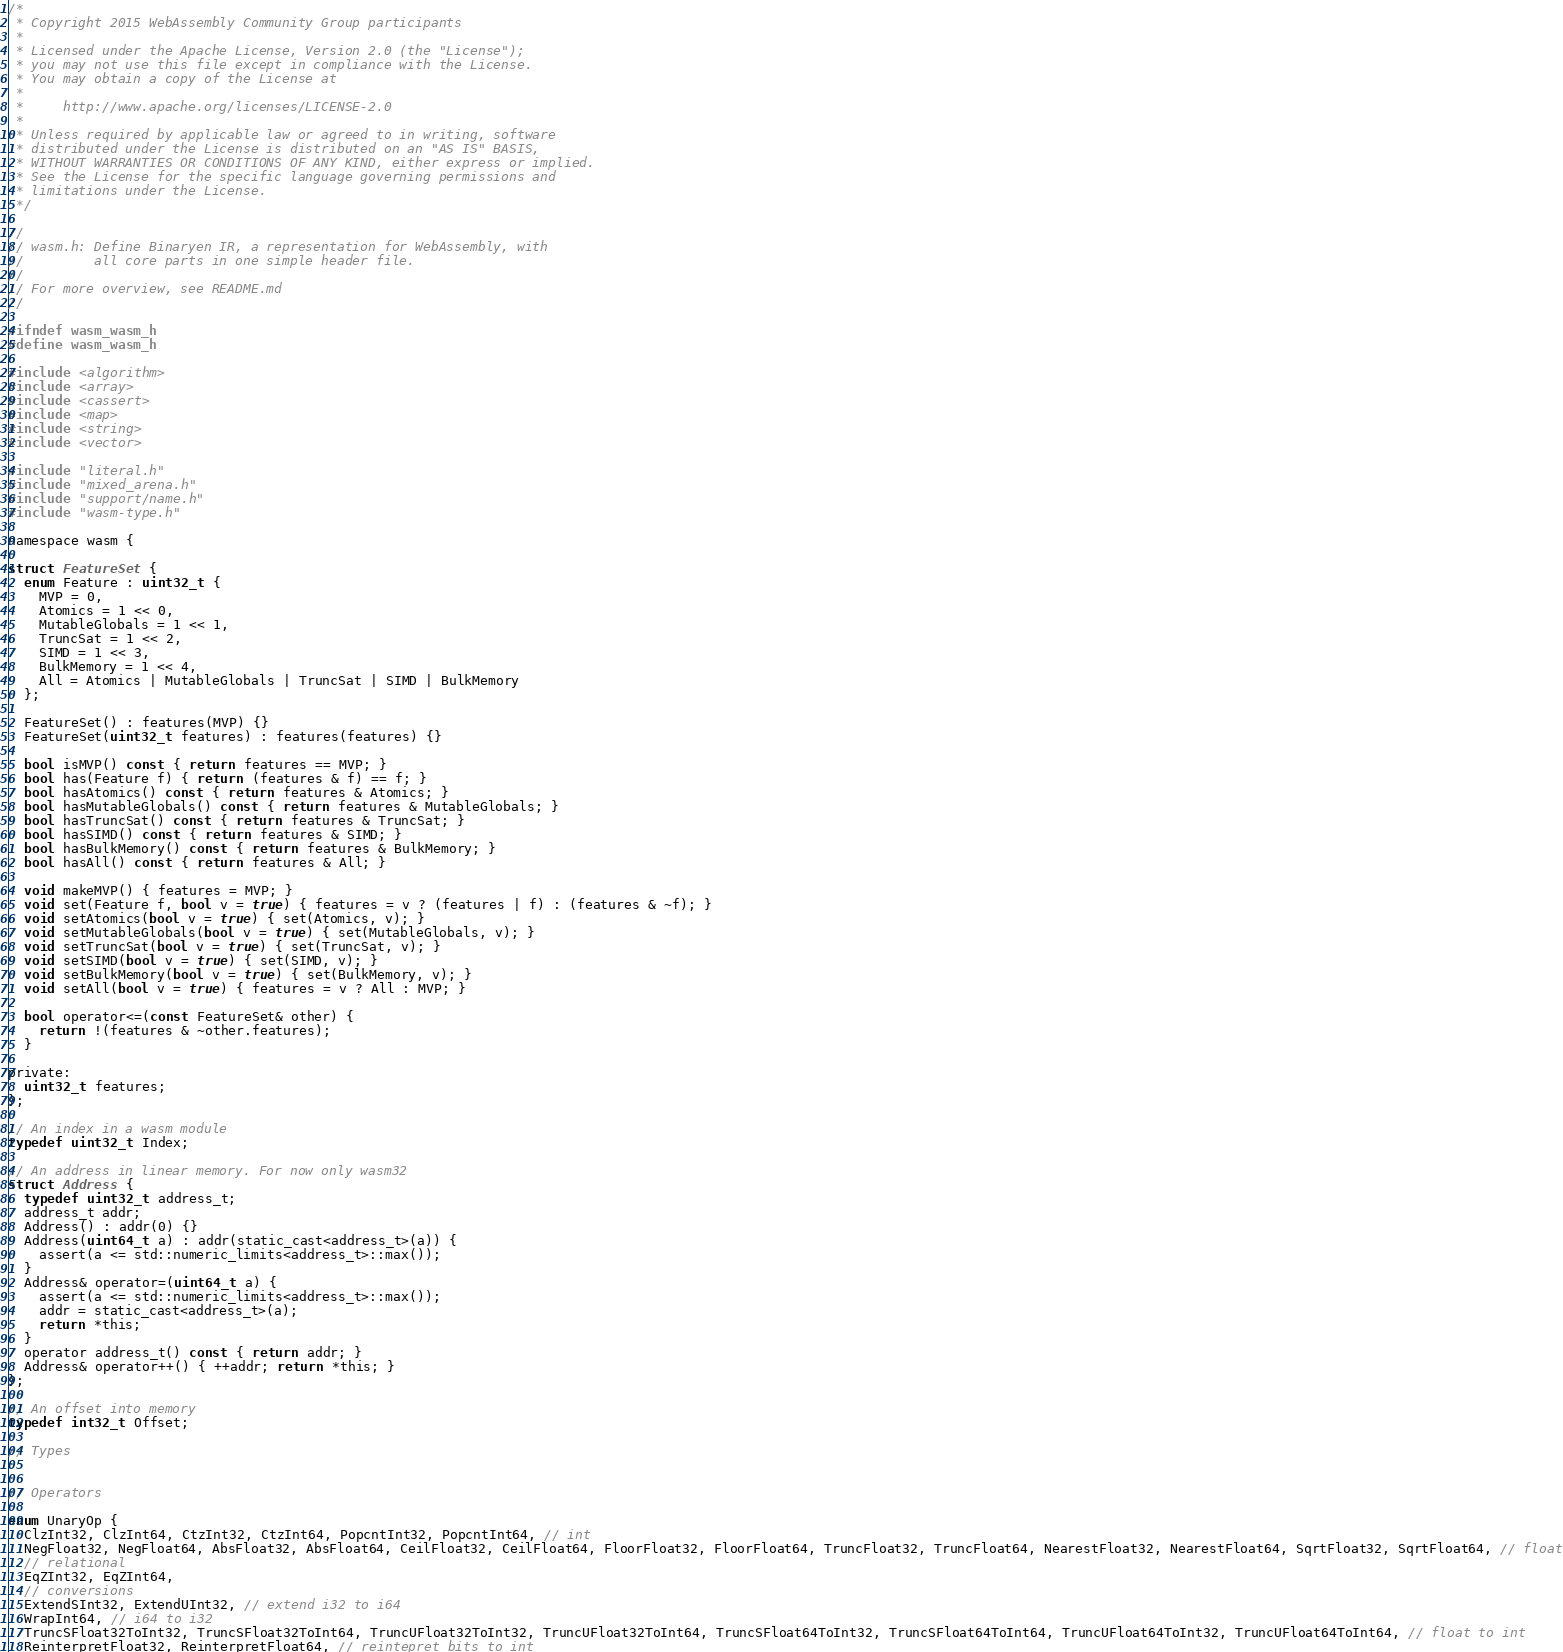Convert code to text. <code><loc_0><loc_0><loc_500><loc_500><_C_>/*
 * Copyright 2015 WebAssembly Community Group participants
 *
 * Licensed under the Apache License, Version 2.0 (the "License");
 * you may not use this file except in compliance with the License.
 * You may obtain a copy of the License at
 *
 *     http://www.apache.org/licenses/LICENSE-2.0
 *
 * Unless required by applicable law or agreed to in writing, software
 * distributed under the License is distributed on an "AS IS" BASIS,
 * WITHOUT WARRANTIES OR CONDITIONS OF ANY KIND, either express or implied.
 * See the License for the specific language governing permissions and
 * limitations under the License.
 */

//
// wasm.h: Define Binaryen IR, a representation for WebAssembly, with
//         all core parts in one simple header file.
//
// For more overview, see README.md
//

#ifndef wasm_wasm_h
#define wasm_wasm_h

#include <algorithm>
#include <array>
#include <cassert>
#include <map>
#include <string>
#include <vector>

#include "literal.h"
#include "mixed_arena.h"
#include "support/name.h"
#include "wasm-type.h"

namespace wasm {

struct FeatureSet {
  enum Feature : uint32_t {
    MVP = 0,
    Atomics = 1 << 0,
    MutableGlobals = 1 << 1,
    TruncSat = 1 << 2,
    SIMD = 1 << 3,
    BulkMemory = 1 << 4,
    All = Atomics | MutableGlobals | TruncSat | SIMD | BulkMemory
  };

  FeatureSet() : features(MVP) {}
  FeatureSet(uint32_t features) : features(features) {}

  bool isMVP() const { return features == MVP; }
  bool has(Feature f) { return (features & f) == f; }
  bool hasAtomics() const { return features & Atomics; }
  bool hasMutableGlobals() const { return features & MutableGlobals; }
  bool hasTruncSat() const { return features & TruncSat; }
  bool hasSIMD() const { return features & SIMD; }
  bool hasBulkMemory() const { return features & BulkMemory; }
  bool hasAll() const { return features & All; }

  void makeMVP() { features = MVP; }
  void set(Feature f, bool v = true) { features = v ? (features | f) : (features & ~f); }
  void setAtomics(bool v = true) { set(Atomics, v); }
  void setMutableGlobals(bool v = true) { set(MutableGlobals, v); }
  void setTruncSat(bool v = true) { set(TruncSat, v); }
  void setSIMD(bool v = true) { set(SIMD, v); }
  void setBulkMemory(bool v = true) { set(BulkMemory, v); }
  void setAll(bool v = true) { features = v ? All : MVP; }

  bool operator<=(const FeatureSet& other) {
    return !(features & ~other.features);
  }

private:
  uint32_t features;
};

// An index in a wasm module
typedef uint32_t Index;

// An address in linear memory. For now only wasm32
struct Address {
  typedef uint32_t address_t;
  address_t addr;
  Address() : addr(0) {}
  Address(uint64_t a) : addr(static_cast<address_t>(a)) {
    assert(a <= std::numeric_limits<address_t>::max());
  }
  Address& operator=(uint64_t a) {
    assert(a <= std::numeric_limits<address_t>::max());
    addr = static_cast<address_t>(a);
    return *this;
  }
  operator address_t() const { return addr; }
  Address& operator++() { ++addr; return *this; }
};

// An offset into memory
typedef int32_t Offset;

// Types


// Operators

enum UnaryOp {
  ClzInt32, ClzInt64, CtzInt32, CtzInt64, PopcntInt32, PopcntInt64, // int
  NegFloat32, NegFloat64, AbsFloat32, AbsFloat64, CeilFloat32, CeilFloat64, FloorFloat32, FloorFloat64, TruncFloat32, TruncFloat64, NearestFloat32, NearestFloat64, SqrtFloat32, SqrtFloat64, // float
  // relational
  EqZInt32, EqZInt64,
  // conversions
  ExtendSInt32, ExtendUInt32, // extend i32 to i64
  WrapInt64, // i64 to i32
  TruncSFloat32ToInt32, TruncSFloat32ToInt64, TruncUFloat32ToInt32, TruncUFloat32ToInt64, TruncSFloat64ToInt32, TruncSFloat64ToInt64, TruncUFloat64ToInt32, TruncUFloat64ToInt64, // float to int
  ReinterpretFloat32, ReinterpretFloat64, // reintepret bits to int</code> 